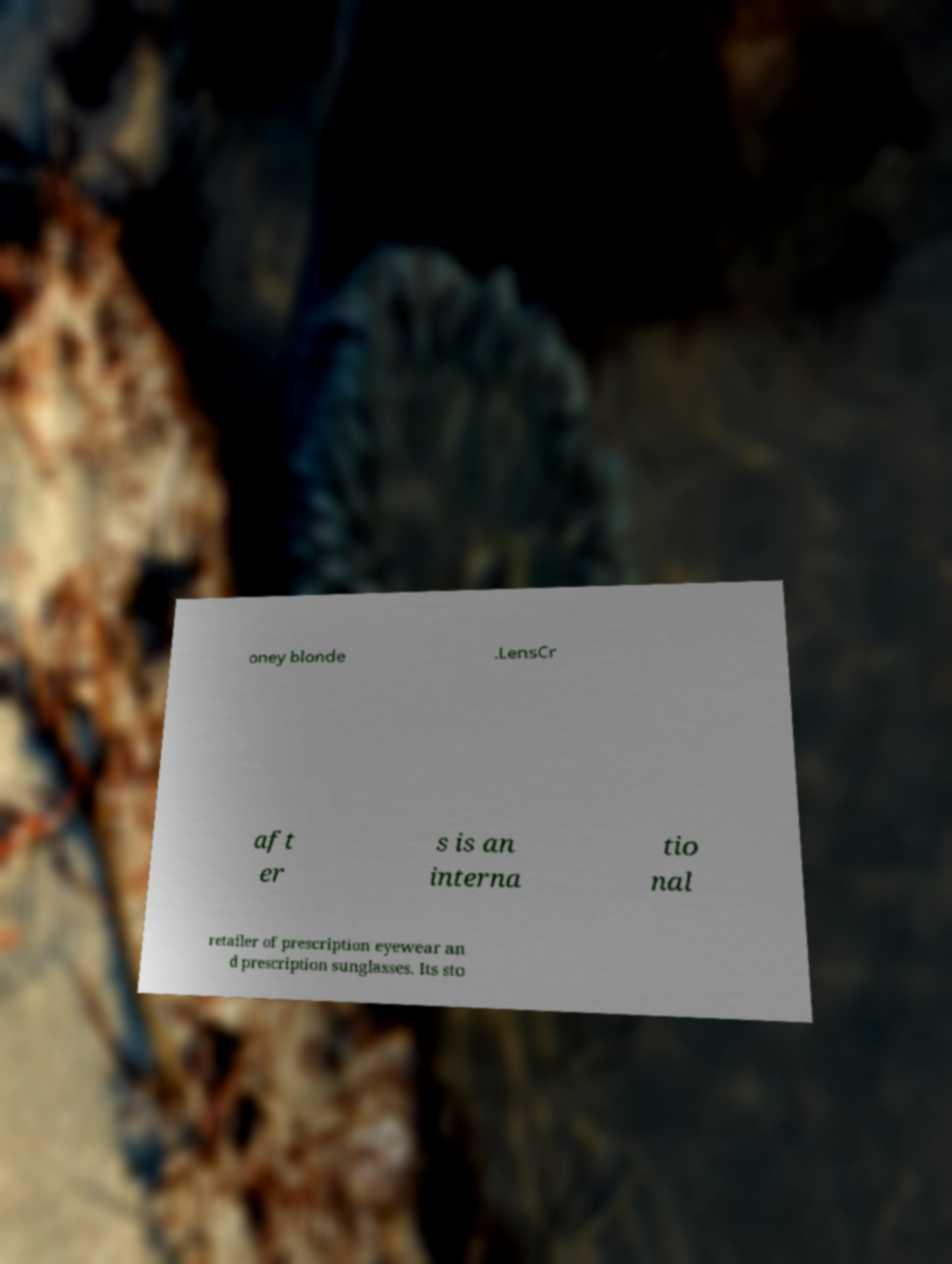Can you read and provide the text displayed in the image?This photo seems to have some interesting text. Can you extract and type it out for me? oney blonde .LensCr aft er s is an interna tio nal retailer of prescription eyewear an d prescription sunglasses. Its sto 